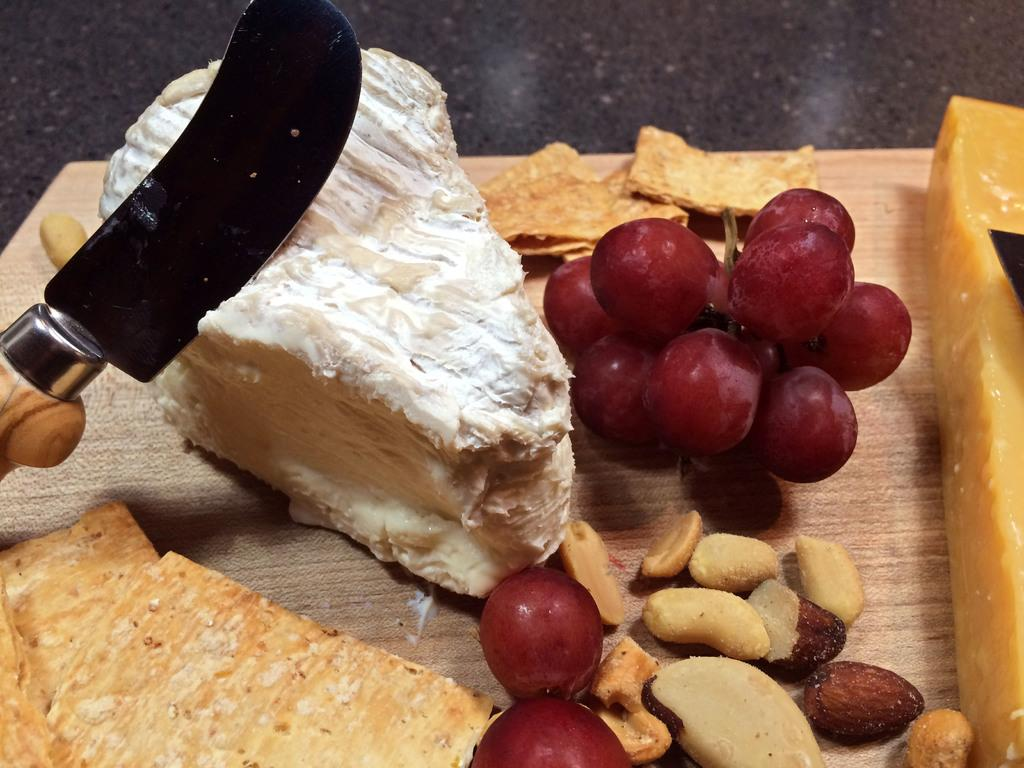What type of food item is in the image? There is a pastry in the image. What fruit is present in the image? Cherries are present in the image. What type of food items are visible in the image besides the pastry? Dry fruits are visible in the image. Where are the items in the image located? The items are kept on a table. What utensil is used on the pastry in the image? There is a knife on the pastry. What type of border is depicted in the image? There is no border depicted in the image; it features a pastry, cherries, dry fruits, a table, and a knife. What is the weather like in the image? The image does not provide any information about the weather. 